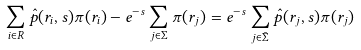Convert formula to latex. <formula><loc_0><loc_0><loc_500><loc_500>\sum _ { i \in R } \hat { p } ( { r } _ { i } , s ) \pi ( { r } _ { i } ) - e ^ { - s } \sum _ { j \in \Sigma } \pi ( { r } _ { j } ) = e ^ { - s } \sum _ { j \in \bar { \Sigma } } \hat { p } ( { r } _ { j } , s ) \pi ( { r } _ { j } )</formula> 